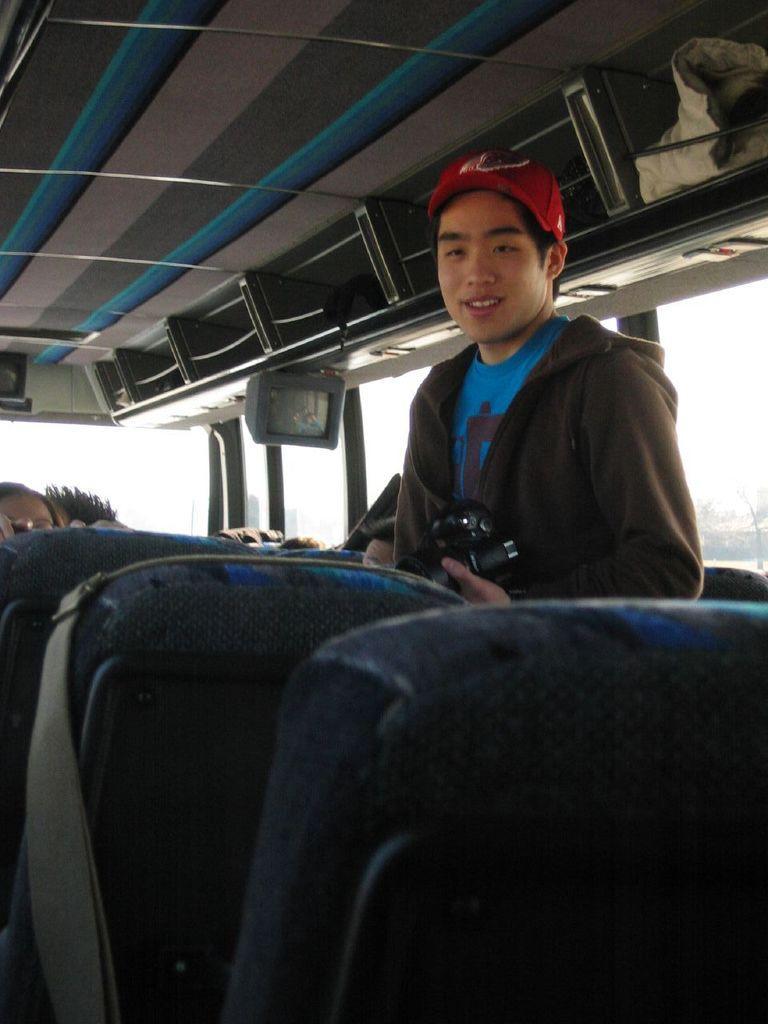How would you summarize this image in a sentence or two? In this picture there are people inside a vehicle and we can see seats, television, glass windows and objects. 